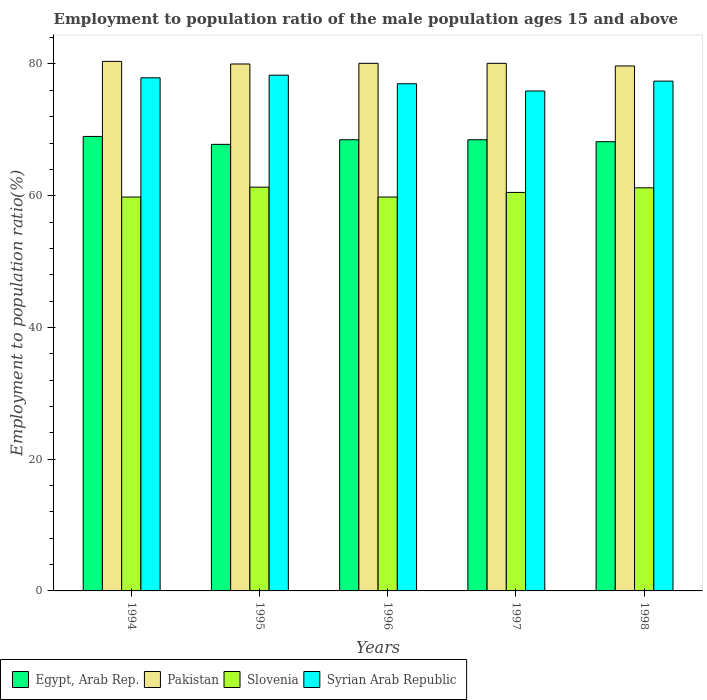How many different coloured bars are there?
Offer a very short reply. 4. Are the number of bars per tick equal to the number of legend labels?
Your answer should be compact. Yes. Are the number of bars on each tick of the X-axis equal?
Make the answer very short. Yes. How many bars are there on the 2nd tick from the right?
Your answer should be compact. 4. What is the employment to population ratio in Slovenia in 1997?
Provide a short and direct response. 60.5. Across all years, what is the maximum employment to population ratio in Pakistan?
Offer a very short reply. 80.4. Across all years, what is the minimum employment to population ratio in Egypt, Arab Rep.?
Your answer should be compact. 67.8. In which year was the employment to population ratio in Syrian Arab Republic minimum?
Your answer should be very brief. 1997. What is the total employment to population ratio in Egypt, Arab Rep. in the graph?
Offer a very short reply. 342. What is the difference between the employment to population ratio in Egypt, Arab Rep. in 1995 and that in 1998?
Keep it short and to the point. -0.4. What is the difference between the employment to population ratio in Egypt, Arab Rep. in 1998 and the employment to population ratio in Slovenia in 1995?
Ensure brevity in your answer.  6.9. What is the average employment to population ratio in Slovenia per year?
Your response must be concise. 60.52. In the year 1996, what is the difference between the employment to population ratio in Slovenia and employment to population ratio in Egypt, Arab Rep.?
Offer a very short reply. -8.7. In how many years, is the employment to population ratio in Syrian Arab Republic greater than 76 %?
Your answer should be very brief. 4. What is the ratio of the employment to population ratio in Pakistan in 1994 to that in 1996?
Ensure brevity in your answer.  1. Is the employment to population ratio in Slovenia in 1994 less than that in 1997?
Your answer should be very brief. Yes. Is the difference between the employment to population ratio in Slovenia in 1995 and 1998 greater than the difference between the employment to population ratio in Egypt, Arab Rep. in 1995 and 1998?
Provide a short and direct response. Yes. What is the difference between the highest and the second highest employment to population ratio in Syrian Arab Republic?
Offer a very short reply. 0.4. What is the difference between the highest and the lowest employment to population ratio in Egypt, Arab Rep.?
Your answer should be compact. 1.2. Is it the case that in every year, the sum of the employment to population ratio in Slovenia and employment to population ratio in Pakistan is greater than the sum of employment to population ratio in Syrian Arab Republic and employment to population ratio in Egypt, Arab Rep.?
Offer a very short reply. Yes. What does the 2nd bar from the left in 1998 represents?
Keep it short and to the point. Pakistan. How many bars are there?
Give a very brief answer. 20. Are all the bars in the graph horizontal?
Make the answer very short. No. What is the difference between two consecutive major ticks on the Y-axis?
Ensure brevity in your answer.  20. Are the values on the major ticks of Y-axis written in scientific E-notation?
Make the answer very short. No. Does the graph contain any zero values?
Offer a terse response. No. How many legend labels are there?
Ensure brevity in your answer.  4. How are the legend labels stacked?
Provide a short and direct response. Horizontal. What is the title of the graph?
Provide a succinct answer. Employment to population ratio of the male population ages 15 and above. What is the label or title of the Y-axis?
Provide a succinct answer. Employment to population ratio(%). What is the Employment to population ratio(%) of Pakistan in 1994?
Keep it short and to the point. 80.4. What is the Employment to population ratio(%) of Slovenia in 1994?
Your response must be concise. 59.8. What is the Employment to population ratio(%) of Syrian Arab Republic in 1994?
Your response must be concise. 77.9. What is the Employment to population ratio(%) of Egypt, Arab Rep. in 1995?
Keep it short and to the point. 67.8. What is the Employment to population ratio(%) of Slovenia in 1995?
Offer a very short reply. 61.3. What is the Employment to population ratio(%) of Syrian Arab Republic in 1995?
Ensure brevity in your answer.  78.3. What is the Employment to population ratio(%) in Egypt, Arab Rep. in 1996?
Your answer should be very brief. 68.5. What is the Employment to population ratio(%) in Pakistan in 1996?
Offer a very short reply. 80.1. What is the Employment to population ratio(%) of Slovenia in 1996?
Your answer should be compact. 59.8. What is the Employment to population ratio(%) in Egypt, Arab Rep. in 1997?
Ensure brevity in your answer.  68.5. What is the Employment to population ratio(%) in Pakistan in 1997?
Offer a terse response. 80.1. What is the Employment to population ratio(%) of Slovenia in 1997?
Provide a short and direct response. 60.5. What is the Employment to population ratio(%) in Syrian Arab Republic in 1997?
Offer a terse response. 75.9. What is the Employment to population ratio(%) in Egypt, Arab Rep. in 1998?
Ensure brevity in your answer.  68.2. What is the Employment to population ratio(%) in Pakistan in 1998?
Make the answer very short. 79.7. What is the Employment to population ratio(%) in Slovenia in 1998?
Your response must be concise. 61.2. What is the Employment to population ratio(%) in Syrian Arab Republic in 1998?
Your response must be concise. 77.4. Across all years, what is the maximum Employment to population ratio(%) in Pakistan?
Give a very brief answer. 80.4. Across all years, what is the maximum Employment to population ratio(%) of Slovenia?
Ensure brevity in your answer.  61.3. Across all years, what is the maximum Employment to population ratio(%) of Syrian Arab Republic?
Your answer should be compact. 78.3. Across all years, what is the minimum Employment to population ratio(%) in Egypt, Arab Rep.?
Your response must be concise. 67.8. Across all years, what is the minimum Employment to population ratio(%) in Pakistan?
Keep it short and to the point. 79.7. Across all years, what is the minimum Employment to population ratio(%) of Slovenia?
Ensure brevity in your answer.  59.8. Across all years, what is the minimum Employment to population ratio(%) in Syrian Arab Republic?
Keep it short and to the point. 75.9. What is the total Employment to population ratio(%) of Egypt, Arab Rep. in the graph?
Ensure brevity in your answer.  342. What is the total Employment to population ratio(%) in Pakistan in the graph?
Your response must be concise. 400.3. What is the total Employment to population ratio(%) in Slovenia in the graph?
Give a very brief answer. 302.6. What is the total Employment to population ratio(%) in Syrian Arab Republic in the graph?
Your answer should be very brief. 386.5. What is the difference between the Employment to population ratio(%) in Pakistan in 1994 and that in 1995?
Offer a terse response. 0.4. What is the difference between the Employment to population ratio(%) in Egypt, Arab Rep. in 1994 and that in 1996?
Give a very brief answer. 0.5. What is the difference between the Employment to population ratio(%) of Pakistan in 1994 and that in 1996?
Ensure brevity in your answer.  0.3. What is the difference between the Employment to population ratio(%) of Slovenia in 1994 and that in 1996?
Offer a very short reply. 0. What is the difference between the Employment to population ratio(%) of Syrian Arab Republic in 1994 and that in 1996?
Keep it short and to the point. 0.9. What is the difference between the Employment to population ratio(%) in Egypt, Arab Rep. in 1994 and that in 1997?
Offer a very short reply. 0.5. What is the difference between the Employment to population ratio(%) in Pakistan in 1994 and that in 1997?
Give a very brief answer. 0.3. What is the difference between the Employment to population ratio(%) of Slovenia in 1994 and that in 1997?
Provide a short and direct response. -0.7. What is the difference between the Employment to population ratio(%) of Egypt, Arab Rep. in 1995 and that in 1996?
Give a very brief answer. -0.7. What is the difference between the Employment to population ratio(%) of Slovenia in 1995 and that in 1997?
Your response must be concise. 0.8. What is the difference between the Employment to population ratio(%) in Syrian Arab Republic in 1995 and that in 1997?
Give a very brief answer. 2.4. What is the difference between the Employment to population ratio(%) in Slovenia in 1995 and that in 1998?
Your response must be concise. 0.1. What is the difference between the Employment to population ratio(%) in Syrian Arab Republic in 1995 and that in 1998?
Offer a very short reply. 0.9. What is the difference between the Employment to population ratio(%) of Egypt, Arab Rep. in 1996 and that in 1997?
Your answer should be very brief. 0. What is the difference between the Employment to population ratio(%) of Pakistan in 1996 and that in 1997?
Keep it short and to the point. 0. What is the difference between the Employment to population ratio(%) in Slovenia in 1996 and that in 1997?
Provide a succinct answer. -0.7. What is the difference between the Employment to population ratio(%) of Pakistan in 1996 and that in 1998?
Provide a succinct answer. 0.4. What is the difference between the Employment to population ratio(%) in Egypt, Arab Rep. in 1994 and the Employment to population ratio(%) in Pakistan in 1995?
Your response must be concise. -11. What is the difference between the Employment to population ratio(%) of Egypt, Arab Rep. in 1994 and the Employment to population ratio(%) of Slovenia in 1995?
Your answer should be very brief. 7.7. What is the difference between the Employment to population ratio(%) of Slovenia in 1994 and the Employment to population ratio(%) of Syrian Arab Republic in 1995?
Provide a short and direct response. -18.5. What is the difference between the Employment to population ratio(%) in Egypt, Arab Rep. in 1994 and the Employment to population ratio(%) in Slovenia in 1996?
Provide a short and direct response. 9.2. What is the difference between the Employment to population ratio(%) in Egypt, Arab Rep. in 1994 and the Employment to population ratio(%) in Syrian Arab Republic in 1996?
Your answer should be compact. -8. What is the difference between the Employment to population ratio(%) in Pakistan in 1994 and the Employment to population ratio(%) in Slovenia in 1996?
Your answer should be very brief. 20.6. What is the difference between the Employment to population ratio(%) of Pakistan in 1994 and the Employment to population ratio(%) of Syrian Arab Republic in 1996?
Make the answer very short. 3.4. What is the difference between the Employment to population ratio(%) of Slovenia in 1994 and the Employment to population ratio(%) of Syrian Arab Republic in 1996?
Your answer should be compact. -17.2. What is the difference between the Employment to population ratio(%) in Egypt, Arab Rep. in 1994 and the Employment to population ratio(%) in Syrian Arab Republic in 1997?
Give a very brief answer. -6.9. What is the difference between the Employment to population ratio(%) in Pakistan in 1994 and the Employment to population ratio(%) in Slovenia in 1997?
Provide a succinct answer. 19.9. What is the difference between the Employment to population ratio(%) of Slovenia in 1994 and the Employment to population ratio(%) of Syrian Arab Republic in 1997?
Your answer should be compact. -16.1. What is the difference between the Employment to population ratio(%) of Egypt, Arab Rep. in 1994 and the Employment to population ratio(%) of Pakistan in 1998?
Ensure brevity in your answer.  -10.7. What is the difference between the Employment to population ratio(%) in Egypt, Arab Rep. in 1994 and the Employment to population ratio(%) in Syrian Arab Republic in 1998?
Offer a very short reply. -8.4. What is the difference between the Employment to population ratio(%) in Slovenia in 1994 and the Employment to population ratio(%) in Syrian Arab Republic in 1998?
Your response must be concise. -17.6. What is the difference between the Employment to population ratio(%) of Egypt, Arab Rep. in 1995 and the Employment to population ratio(%) of Syrian Arab Republic in 1996?
Your answer should be compact. -9.2. What is the difference between the Employment to population ratio(%) in Pakistan in 1995 and the Employment to population ratio(%) in Slovenia in 1996?
Keep it short and to the point. 20.2. What is the difference between the Employment to population ratio(%) of Slovenia in 1995 and the Employment to population ratio(%) of Syrian Arab Republic in 1996?
Offer a terse response. -15.7. What is the difference between the Employment to population ratio(%) of Egypt, Arab Rep. in 1995 and the Employment to population ratio(%) of Slovenia in 1997?
Offer a terse response. 7.3. What is the difference between the Employment to population ratio(%) in Egypt, Arab Rep. in 1995 and the Employment to population ratio(%) in Syrian Arab Republic in 1997?
Make the answer very short. -8.1. What is the difference between the Employment to population ratio(%) of Pakistan in 1995 and the Employment to population ratio(%) of Syrian Arab Republic in 1997?
Offer a terse response. 4.1. What is the difference between the Employment to population ratio(%) of Slovenia in 1995 and the Employment to population ratio(%) of Syrian Arab Republic in 1997?
Your answer should be compact. -14.6. What is the difference between the Employment to population ratio(%) in Egypt, Arab Rep. in 1995 and the Employment to population ratio(%) in Pakistan in 1998?
Your response must be concise. -11.9. What is the difference between the Employment to population ratio(%) in Pakistan in 1995 and the Employment to population ratio(%) in Syrian Arab Republic in 1998?
Offer a terse response. 2.6. What is the difference between the Employment to population ratio(%) of Slovenia in 1995 and the Employment to population ratio(%) of Syrian Arab Republic in 1998?
Provide a short and direct response. -16.1. What is the difference between the Employment to population ratio(%) of Egypt, Arab Rep. in 1996 and the Employment to population ratio(%) of Syrian Arab Republic in 1997?
Give a very brief answer. -7.4. What is the difference between the Employment to population ratio(%) of Pakistan in 1996 and the Employment to population ratio(%) of Slovenia in 1997?
Ensure brevity in your answer.  19.6. What is the difference between the Employment to population ratio(%) of Slovenia in 1996 and the Employment to population ratio(%) of Syrian Arab Republic in 1997?
Offer a very short reply. -16.1. What is the difference between the Employment to population ratio(%) in Egypt, Arab Rep. in 1996 and the Employment to population ratio(%) in Pakistan in 1998?
Ensure brevity in your answer.  -11.2. What is the difference between the Employment to population ratio(%) in Egypt, Arab Rep. in 1996 and the Employment to population ratio(%) in Slovenia in 1998?
Make the answer very short. 7.3. What is the difference between the Employment to population ratio(%) of Egypt, Arab Rep. in 1996 and the Employment to population ratio(%) of Syrian Arab Republic in 1998?
Offer a terse response. -8.9. What is the difference between the Employment to population ratio(%) in Pakistan in 1996 and the Employment to population ratio(%) in Syrian Arab Republic in 1998?
Provide a short and direct response. 2.7. What is the difference between the Employment to population ratio(%) in Slovenia in 1996 and the Employment to population ratio(%) in Syrian Arab Republic in 1998?
Your answer should be very brief. -17.6. What is the difference between the Employment to population ratio(%) in Egypt, Arab Rep. in 1997 and the Employment to population ratio(%) in Slovenia in 1998?
Make the answer very short. 7.3. What is the difference between the Employment to population ratio(%) of Egypt, Arab Rep. in 1997 and the Employment to population ratio(%) of Syrian Arab Republic in 1998?
Keep it short and to the point. -8.9. What is the difference between the Employment to population ratio(%) of Pakistan in 1997 and the Employment to population ratio(%) of Slovenia in 1998?
Provide a short and direct response. 18.9. What is the difference between the Employment to population ratio(%) of Slovenia in 1997 and the Employment to population ratio(%) of Syrian Arab Republic in 1998?
Give a very brief answer. -16.9. What is the average Employment to population ratio(%) in Egypt, Arab Rep. per year?
Offer a terse response. 68.4. What is the average Employment to population ratio(%) in Pakistan per year?
Offer a very short reply. 80.06. What is the average Employment to population ratio(%) of Slovenia per year?
Keep it short and to the point. 60.52. What is the average Employment to population ratio(%) in Syrian Arab Republic per year?
Ensure brevity in your answer.  77.3. In the year 1994, what is the difference between the Employment to population ratio(%) in Egypt, Arab Rep. and Employment to population ratio(%) in Pakistan?
Offer a very short reply. -11.4. In the year 1994, what is the difference between the Employment to population ratio(%) in Egypt, Arab Rep. and Employment to population ratio(%) in Slovenia?
Provide a succinct answer. 9.2. In the year 1994, what is the difference between the Employment to population ratio(%) of Egypt, Arab Rep. and Employment to population ratio(%) of Syrian Arab Republic?
Ensure brevity in your answer.  -8.9. In the year 1994, what is the difference between the Employment to population ratio(%) in Pakistan and Employment to population ratio(%) in Slovenia?
Your answer should be very brief. 20.6. In the year 1994, what is the difference between the Employment to population ratio(%) of Pakistan and Employment to population ratio(%) of Syrian Arab Republic?
Provide a short and direct response. 2.5. In the year 1994, what is the difference between the Employment to population ratio(%) in Slovenia and Employment to population ratio(%) in Syrian Arab Republic?
Your answer should be compact. -18.1. In the year 1995, what is the difference between the Employment to population ratio(%) in Egypt, Arab Rep. and Employment to population ratio(%) in Pakistan?
Provide a short and direct response. -12.2. In the year 1995, what is the difference between the Employment to population ratio(%) in Egypt, Arab Rep. and Employment to population ratio(%) in Syrian Arab Republic?
Keep it short and to the point. -10.5. In the year 1995, what is the difference between the Employment to population ratio(%) in Slovenia and Employment to population ratio(%) in Syrian Arab Republic?
Give a very brief answer. -17. In the year 1996, what is the difference between the Employment to population ratio(%) of Egypt, Arab Rep. and Employment to population ratio(%) of Slovenia?
Make the answer very short. 8.7. In the year 1996, what is the difference between the Employment to population ratio(%) of Pakistan and Employment to population ratio(%) of Slovenia?
Provide a succinct answer. 20.3. In the year 1996, what is the difference between the Employment to population ratio(%) in Slovenia and Employment to population ratio(%) in Syrian Arab Republic?
Make the answer very short. -17.2. In the year 1997, what is the difference between the Employment to population ratio(%) in Egypt, Arab Rep. and Employment to population ratio(%) in Slovenia?
Provide a short and direct response. 8. In the year 1997, what is the difference between the Employment to population ratio(%) of Pakistan and Employment to population ratio(%) of Slovenia?
Ensure brevity in your answer.  19.6. In the year 1997, what is the difference between the Employment to population ratio(%) of Pakistan and Employment to population ratio(%) of Syrian Arab Republic?
Give a very brief answer. 4.2. In the year 1997, what is the difference between the Employment to population ratio(%) in Slovenia and Employment to population ratio(%) in Syrian Arab Republic?
Your response must be concise. -15.4. In the year 1998, what is the difference between the Employment to population ratio(%) of Egypt, Arab Rep. and Employment to population ratio(%) of Pakistan?
Provide a succinct answer. -11.5. In the year 1998, what is the difference between the Employment to population ratio(%) in Egypt, Arab Rep. and Employment to population ratio(%) in Slovenia?
Your answer should be compact. 7. In the year 1998, what is the difference between the Employment to population ratio(%) in Egypt, Arab Rep. and Employment to population ratio(%) in Syrian Arab Republic?
Your answer should be very brief. -9.2. In the year 1998, what is the difference between the Employment to population ratio(%) of Slovenia and Employment to population ratio(%) of Syrian Arab Republic?
Your response must be concise. -16.2. What is the ratio of the Employment to population ratio(%) in Egypt, Arab Rep. in 1994 to that in 1995?
Provide a succinct answer. 1.02. What is the ratio of the Employment to population ratio(%) in Pakistan in 1994 to that in 1995?
Your response must be concise. 1. What is the ratio of the Employment to population ratio(%) in Slovenia in 1994 to that in 1995?
Your response must be concise. 0.98. What is the ratio of the Employment to population ratio(%) in Syrian Arab Republic in 1994 to that in 1995?
Your response must be concise. 0.99. What is the ratio of the Employment to population ratio(%) of Egypt, Arab Rep. in 1994 to that in 1996?
Your answer should be compact. 1.01. What is the ratio of the Employment to population ratio(%) in Pakistan in 1994 to that in 1996?
Give a very brief answer. 1. What is the ratio of the Employment to population ratio(%) of Slovenia in 1994 to that in 1996?
Offer a very short reply. 1. What is the ratio of the Employment to population ratio(%) of Syrian Arab Republic in 1994 to that in 1996?
Give a very brief answer. 1.01. What is the ratio of the Employment to population ratio(%) of Egypt, Arab Rep. in 1994 to that in 1997?
Offer a terse response. 1.01. What is the ratio of the Employment to population ratio(%) in Slovenia in 1994 to that in 1997?
Provide a short and direct response. 0.99. What is the ratio of the Employment to population ratio(%) in Syrian Arab Republic in 1994 to that in 1997?
Provide a short and direct response. 1.03. What is the ratio of the Employment to population ratio(%) of Egypt, Arab Rep. in 1994 to that in 1998?
Your response must be concise. 1.01. What is the ratio of the Employment to population ratio(%) of Pakistan in 1994 to that in 1998?
Provide a succinct answer. 1.01. What is the ratio of the Employment to population ratio(%) of Slovenia in 1994 to that in 1998?
Ensure brevity in your answer.  0.98. What is the ratio of the Employment to population ratio(%) in Egypt, Arab Rep. in 1995 to that in 1996?
Offer a terse response. 0.99. What is the ratio of the Employment to population ratio(%) in Slovenia in 1995 to that in 1996?
Offer a terse response. 1.03. What is the ratio of the Employment to population ratio(%) of Syrian Arab Republic in 1995 to that in 1996?
Offer a terse response. 1.02. What is the ratio of the Employment to population ratio(%) in Egypt, Arab Rep. in 1995 to that in 1997?
Offer a very short reply. 0.99. What is the ratio of the Employment to population ratio(%) in Slovenia in 1995 to that in 1997?
Provide a short and direct response. 1.01. What is the ratio of the Employment to population ratio(%) in Syrian Arab Republic in 1995 to that in 1997?
Give a very brief answer. 1.03. What is the ratio of the Employment to population ratio(%) in Egypt, Arab Rep. in 1995 to that in 1998?
Your response must be concise. 0.99. What is the ratio of the Employment to population ratio(%) in Syrian Arab Republic in 1995 to that in 1998?
Provide a short and direct response. 1.01. What is the ratio of the Employment to population ratio(%) in Egypt, Arab Rep. in 1996 to that in 1997?
Offer a terse response. 1. What is the ratio of the Employment to population ratio(%) of Pakistan in 1996 to that in 1997?
Give a very brief answer. 1. What is the ratio of the Employment to population ratio(%) of Slovenia in 1996 to that in 1997?
Provide a succinct answer. 0.99. What is the ratio of the Employment to population ratio(%) of Syrian Arab Republic in 1996 to that in 1997?
Your answer should be compact. 1.01. What is the ratio of the Employment to population ratio(%) of Slovenia in 1996 to that in 1998?
Your answer should be very brief. 0.98. What is the ratio of the Employment to population ratio(%) of Syrian Arab Republic in 1996 to that in 1998?
Your response must be concise. 0.99. What is the ratio of the Employment to population ratio(%) in Pakistan in 1997 to that in 1998?
Offer a very short reply. 1. What is the ratio of the Employment to population ratio(%) of Slovenia in 1997 to that in 1998?
Your answer should be very brief. 0.99. What is the ratio of the Employment to population ratio(%) of Syrian Arab Republic in 1997 to that in 1998?
Provide a short and direct response. 0.98. What is the difference between the highest and the second highest Employment to population ratio(%) of Egypt, Arab Rep.?
Ensure brevity in your answer.  0.5. What is the difference between the highest and the second highest Employment to population ratio(%) in Pakistan?
Provide a short and direct response. 0.3. What is the difference between the highest and the second highest Employment to population ratio(%) of Slovenia?
Offer a terse response. 0.1. What is the difference between the highest and the second highest Employment to population ratio(%) in Syrian Arab Republic?
Provide a short and direct response. 0.4. What is the difference between the highest and the lowest Employment to population ratio(%) of Pakistan?
Your response must be concise. 0.7. 